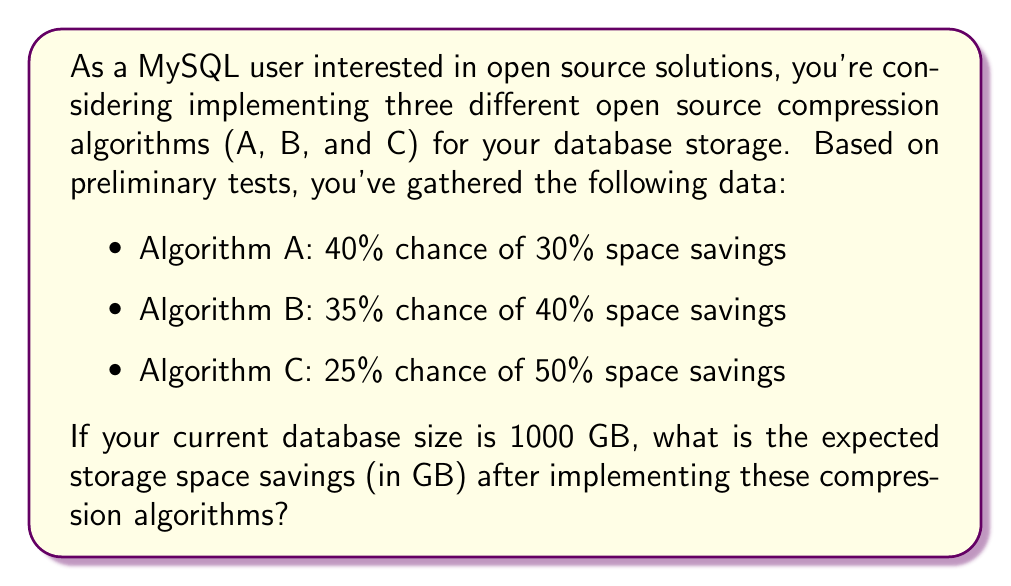Can you solve this math problem? To solve this problem, we need to calculate the expected value of the storage space savings. Let's break it down step by step:

1. Calculate the expected savings for each algorithm:

   Algorithm A: $E(A) = 0.40 \times 0.30 \times 1000 = 120$ GB
   Algorithm B: $E(B) = 0.35 \times 0.40 \times 1000 = 140$ GB
   Algorithm C: $E(C) = 0.25 \times 0.50 \times 1000 = 125$ GB

2. Sum up the expected savings from all algorithms:

   $$E(\text{total savings}) = E(A) + E(B) + E(C)$$
   $$E(\text{total savings}) = 120 + 140 + 125 = 385\text{ GB}$$

Therefore, the expected storage space savings after implementing these compression algorithms is 385 GB.
Answer: 385 GB 